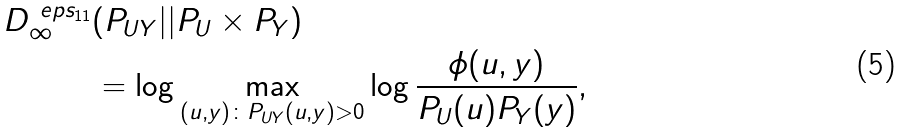<formula> <loc_0><loc_0><loc_500><loc_500>D ^ { \ e p s _ { 1 1 } } _ { \infty } & ( P _ { U Y } | | P _ { U } \times P _ { Y } ) \\ & = \log \max _ { ( u , y ) \colon P _ { U Y } ( u , y ) > 0 } \log \frac { \phi ( u , y ) } { P _ { U } ( u ) P _ { Y } ( y ) } ,</formula> 